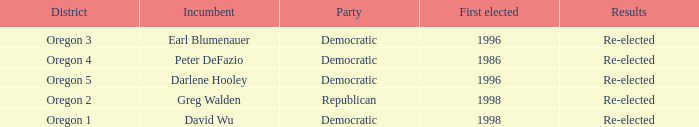Give me the full table as a dictionary. {'header': ['District', 'Incumbent', 'Party', 'First elected', 'Results'], 'rows': [['Oregon 3', 'Earl Blumenauer', 'Democratic', '1996', 'Re-elected'], ['Oregon 4', 'Peter DeFazio', 'Democratic', '1986', 'Re-elected'], ['Oregon 5', 'Darlene Hooley', 'Democratic', '1996', 'Re-elected'], ['Oregon 2', 'Greg Walden', 'Republican', '1998', 'Re-elected'], ['Oregon 1', 'David Wu', 'Democratic', '1998', 'Re-elected']]} What was the result of the Oregon 5 District incumbent who was first elected in 1996? Re-elected. 